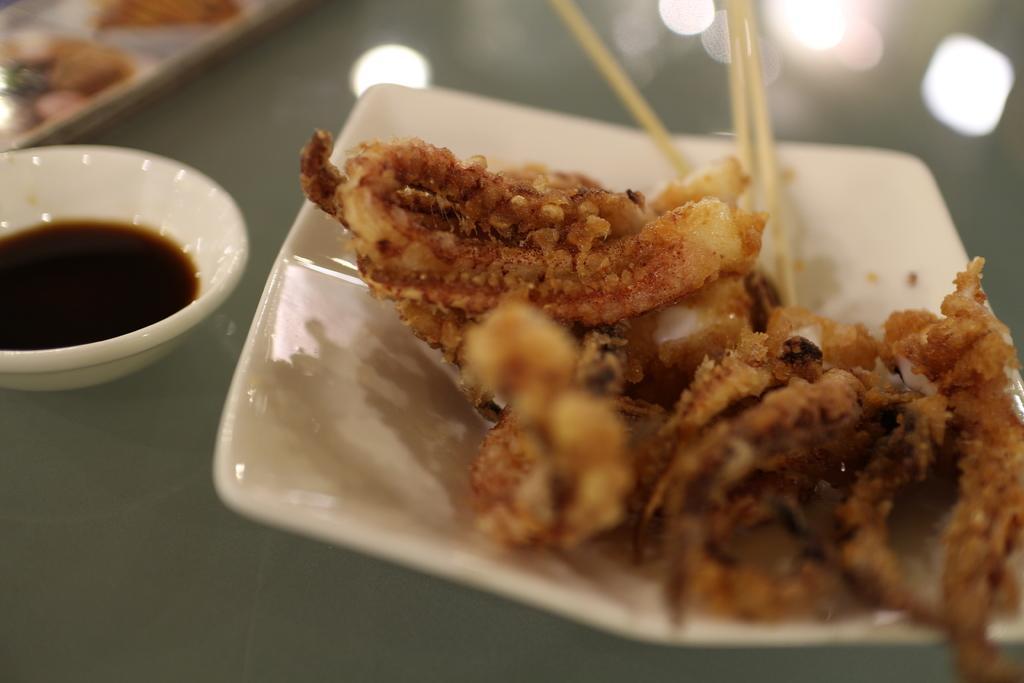How would you summarize this image in a sentence or two? In this image we can see a food item on the plate. Beside the plate there is a bowl with sauce. At the top of the image there are some reflections and other objects. 